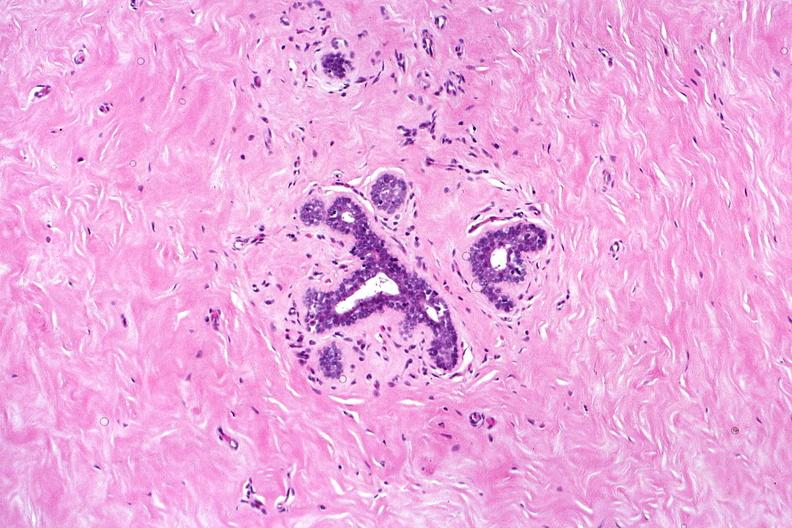where is this from?
Answer the question using a single word or phrase. Female reproductive system 